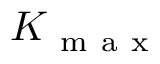<formula> <loc_0><loc_0><loc_500><loc_500>K _ { m a x }</formula> 